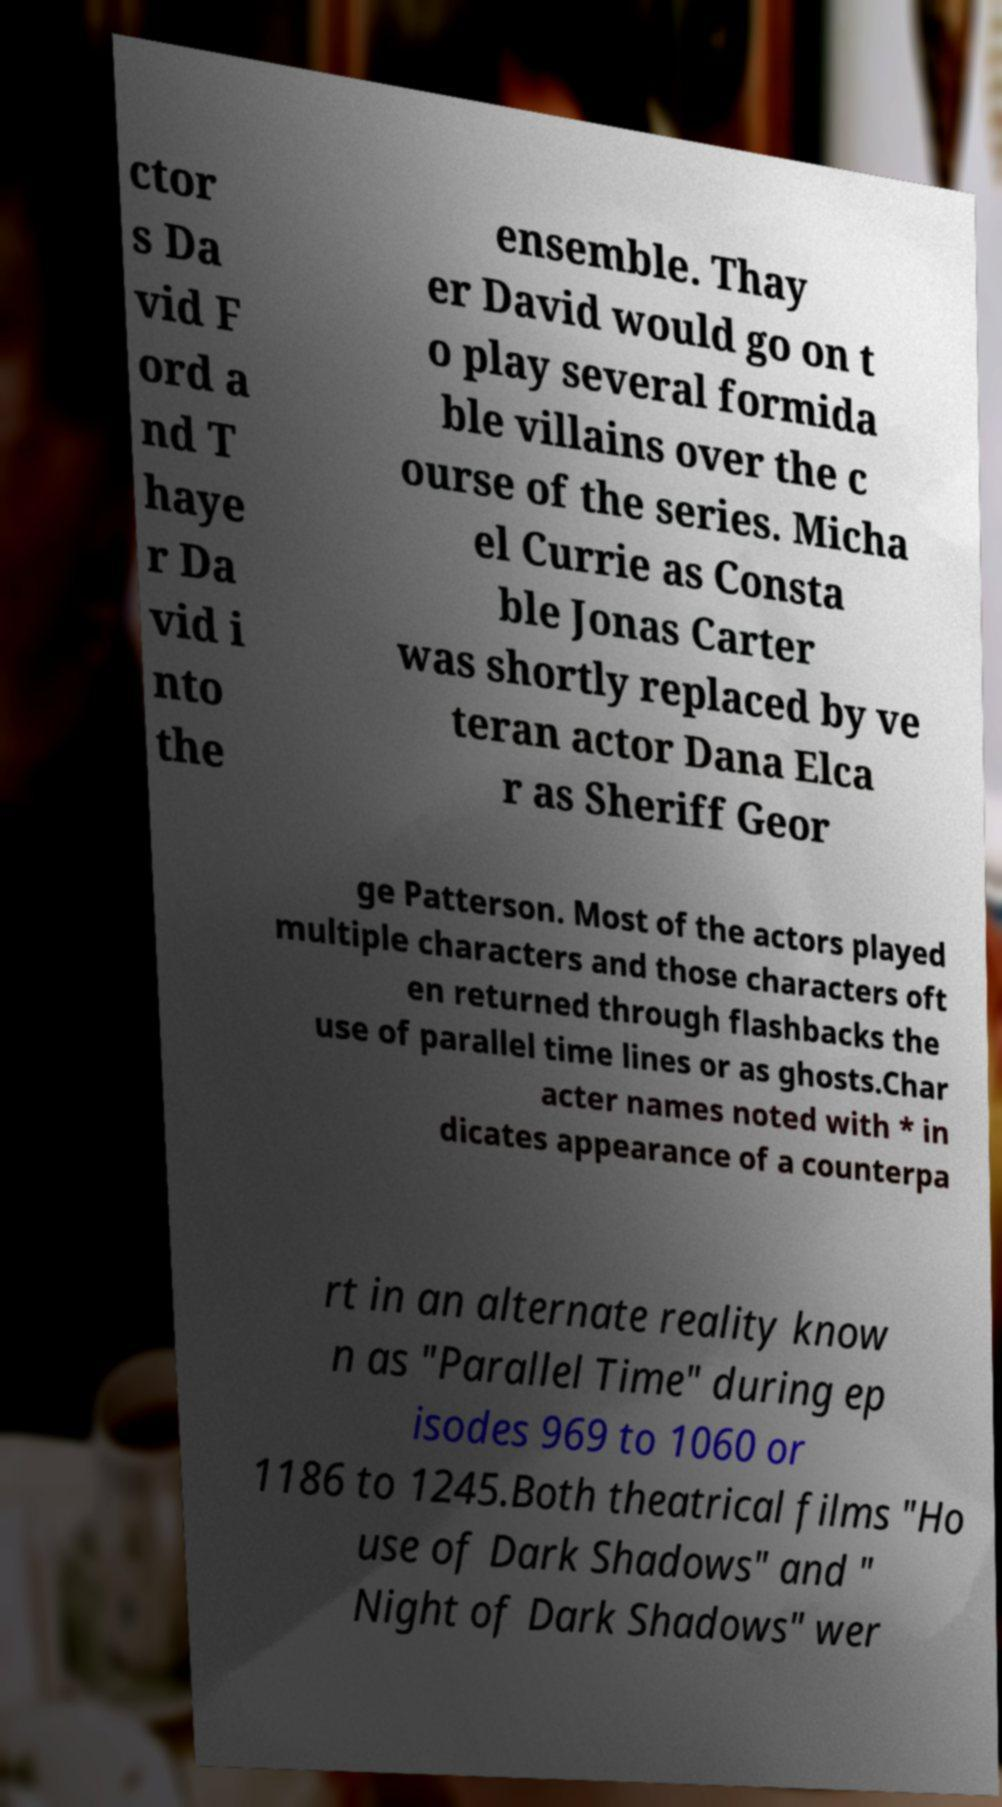I need the written content from this picture converted into text. Can you do that? ctor s Da vid F ord a nd T haye r Da vid i nto the ensemble. Thay er David would go on t o play several formida ble villains over the c ourse of the series. Micha el Currie as Consta ble Jonas Carter was shortly replaced by ve teran actor Dana Elca r as Sheriff Geor ge Patterson. Most of the actors played multiple characters and those characters oft en returned through flashbacks the use of parallel time lines or as ghosts.Char acter names noted with * in dicates appearance of a counterpa rt in an alternate reality know n as "Parallel Time" during ep isodes 969 to 1060 or 1186 to 1245.Both theatrical films "Ho use of Dark Shadows" and " Night of Dark Shadows" wer 